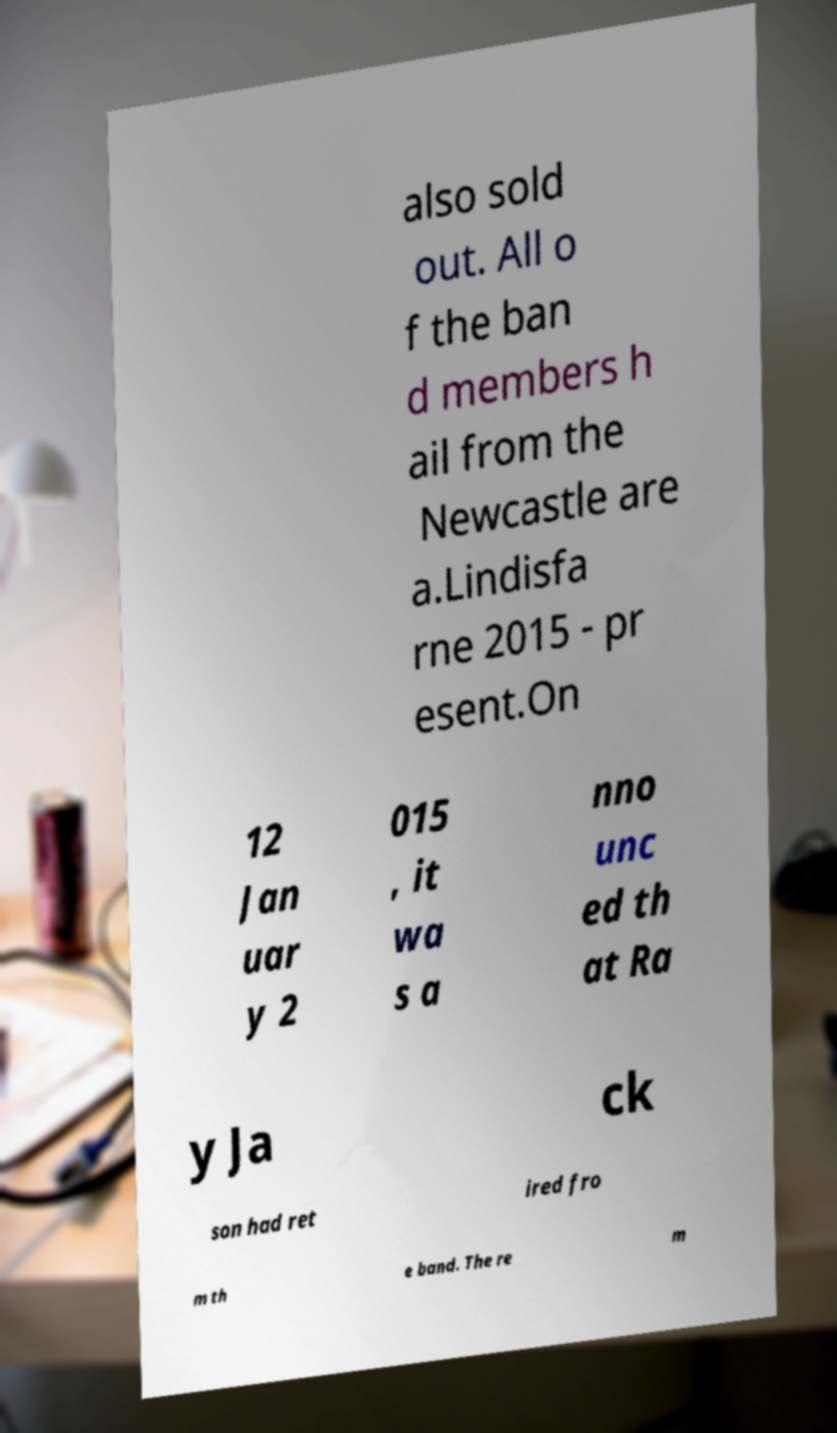For documentation purposes, I need the text within this image transcribed. Could you provide that? also sold out. All o f the ban d members h ail from the Newcastle are a.Lindisfa rne 2015 - pr esent.On 12 Jan uar y 2 015 , it wa s a nno unc ed th at Ra y Ja ck son had ret ired fro m th e band. The re m 